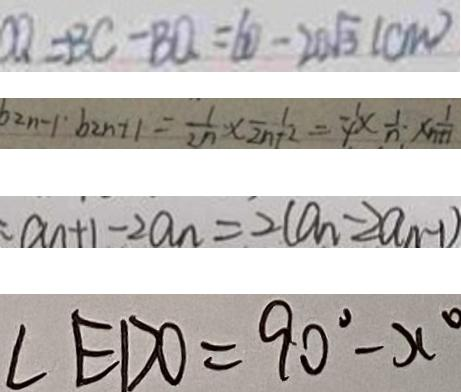<formula> <loc_0><loc_0><loc_500><loc_500>C Q = B C - B Q = 6 0 - 2 0 \sqrt { 3 } ( c m ) 
 b _ { 2 n - 1 } \cdot b _ { 2 n + 1 } = \frac { 1 } { 2 n } \times \frac { 1 } { 2 n + 2 } = \frac { 1 } { 4 } \times \frac { 1 } { n } \cdot \times \frac { 1 } { n + 1 } 
 a _ { n + 1 } - 2 a _ { n } = 2 ( a _ { n } - 2 a _ { n - 1 } ) 
 \angle E D O = 9 0 ^ { \circ } - x ^ { \circ }</formula> 